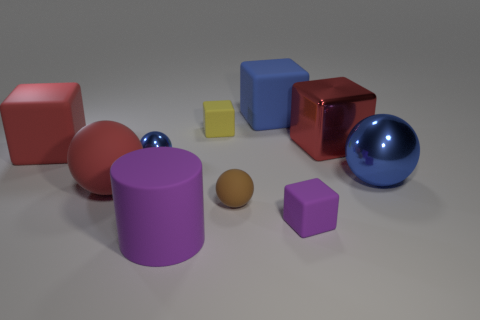There is a blue shiny thing that is right of the tiny rubber block that is right of the brown matte ball; what shape is it?
Make the answer very short. Sphere. Is there any other thing that has the same color as the tiny matte sphere?
Offer a very short reply. No. There is a red block that is on the right side of the red object that is in front of the large blue metallic ball; is there a big blue shiny thing on the left side of it?
Your response must be concise. No. Do the tiny rubber block on the left side of the small purple rubber thing and the big rubber block on the left side of the big purple thing have the same color?
Offer a terse response. No. There is a blue object that is the same size as the brown sphere; what material is it?
Offer a very short reply. Metal. There is a shiny thing on the right side of the red block on the right side of the big rubber block to the right of the big red sphere; what size is it?
Offer a very short reply. Large. How many other objects are the same material as the small brown sphere?
Your response must be concise. 6. There is a sphere to the right of the tiny purple rubber cube; what is its size?
Provide a succinct answer. Large. What number of matte things are behind the metallic cube and to the left of the tiny matte sphere?
Ensure brevity in your answer.  1. What is the material of the large blue thing left of the block that is in front of the big metallic ball?
Ensure brevity in your answer.  Rubber. 